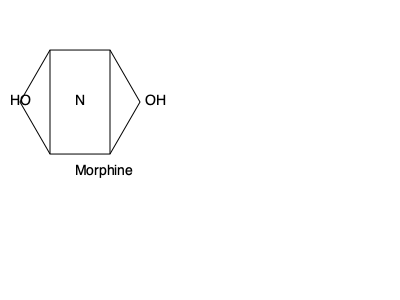Analyze the chemical structure of morphine shown above. Which functional group is responsible for its ability to cross the blood-brain barrier and interact with opioid receptors? To answer this question, we need to consider the following steps:

1. Identify the key functional groups in the morphine structure:
   - Phenol group (HO-)
   - Alcohol group (-OH)
   - Tertiary amine group (-N-)

2. Understand the blood-brain barrier (BBB):
   - The BBB is a selective semipermeable border that separates the circulating blood from the brain extracellular fluid.
   - Molecules that can cross the BBB are typically small and lipophilic.

3. Consider the properties of the functional groups:
   - Phenol and alcohol groups are polar and hydrophilic, which generally reduces lipophilicity.
   - Tertiary amines can exist in both protonated (charged) and unprotonated (uncharged) forms.

4. Analyze the behavior of the tertiary amine:
   - At physiological pH, the tertiary amine can be partially protonated.
   - In its unprotonated form, it is more lipophilic and can cross the BBB.
   - Once inside the brain, it can become protonated again, allowing it to interact with opioid receptors.

5. Conclude:
   - The tertiary amine group is crucial for morphine's ability to cross the BBB and interact with opioid receptors due to its pH-dependent protonation state.
Answer: Tertiary amine group 